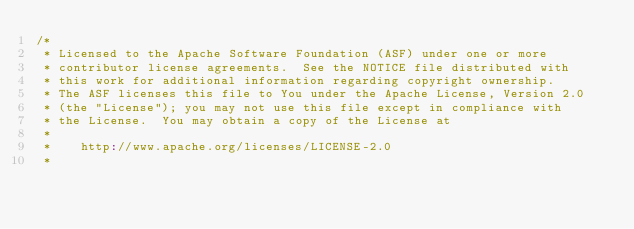<code> <loc_0><loc_0><loc_500><loc_500><_Scala_>/*
 * Licensed to the Apache Software Foundation (ASF) under one or more
 * contributor license agreements.  See the NOTICE file distributed with
 * this work for additional information regarding copyright ownership.
 * The ASF licenses this file to You under the Apache License, Version 2.0
 * (the "License"); you may not use this file except in compliance with
 * the License.  You may obtain a copy of the License at
 *
 *    http://www.apache.org/licenses/LICENSE-2.0
 *</code> 